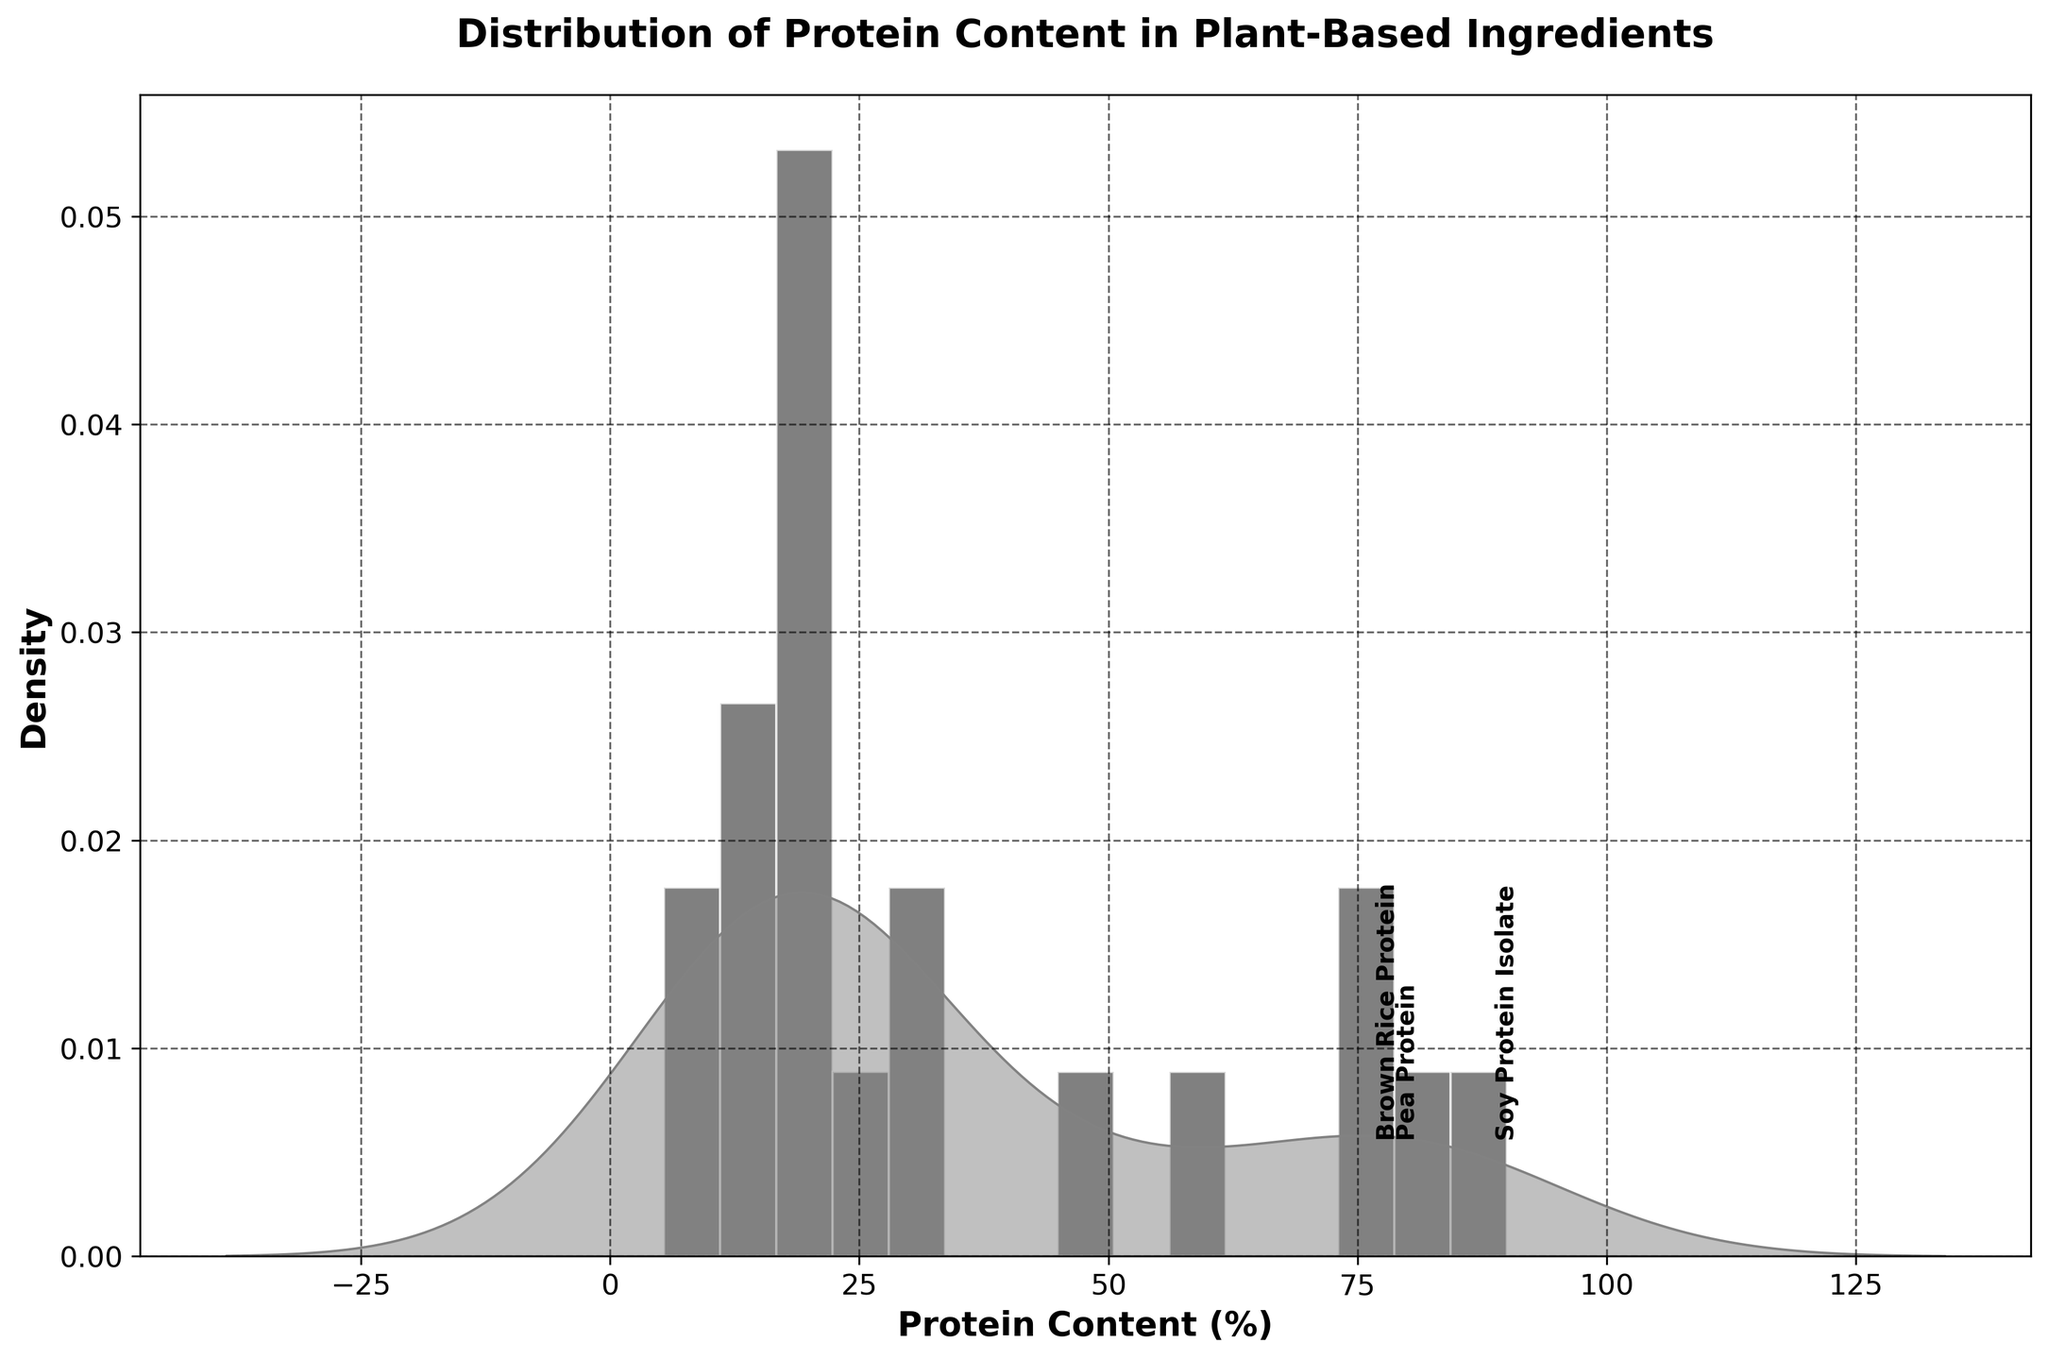What is the main title of the figure? The main title of a figure is usually placed at the top and provides a summary of the content. In this case, the title says, "Distribution of Protein Content in Plant-Based Ingredients," which summarizes the focus of the histogram and KDE plot.
Answer: Distribution of Protein Content in Plant-Based Ingredients What does the X-axis of the figure represent? The label along the X-axis indicates what it is measuring. Here, it is labeled "Protein Content (%)" which means the X-axis represents the protein content percentage in the ingredients.
Answer: Protein Content (%) How many bins are used in the histogram? The histogram bins can be counted along the X-axis. Each vertical bar represents a bin, and there are 15 bins shown in the figure.
Answer: 15 What color are the KDE and histogram density curves? The KDE curve and the histogram density fills are distinguished by their shading. The histogram density fills are a lighter grey color while the KDE curve is a darker grey, almost black, and slightly transparent.
Answer: The KDE is dark grey, and the histogram is light grey Which ingredient is annotated at a protein content greater than 75% but less than 90%? To find specific annotations, look for labels in the figure at the respective positions. "Seitan" appears annotated around the 75% protein content mark.
Answer: Seitan What is the highest protein content percentage shown in the figure? The data range can be inferred from the figure, specifically along the x-axis. Soy Protein Isolate, which is 90%, represents the highest protein content.
Answer: 90% What is the mean protein content percentage in the ingredients? To calculate the mean, sum all the protein content percentages and divide by the number of ingredients. (20.5 + 24.6 + 80.0 + 14.1 + 90.0 + 57.5 + 30.2 + 16.5 + 31.6 + 50.0 + 78.0 + 16.9 + 21.1 + 20.8 + 75.0 + 19.5 + 13.6 + 11.0 + 18.3 + 5.4) / 20 ≈ 34.8
Answer: ~34.8% Which ingredient has the lowest protein content percentage? From the visual plot, the X-axis marking starts from 0 up to 100. The smallest value marked appears near the origin and is associated with Green Peas, which has a protein content of 5.4%.
Answer: Green Peas How does the protein content of Brown Rice Protein compare to Pumpkin Seeds? By checking the placement of 'Brown Rice Protein' and 'Pumpkin Seeds' along the X-axis, it is evident that Brown Rice Protein (78%) is much higher than Pumpkin Seeds (30.2%).
Answer: Brown Rice Protein is higher 